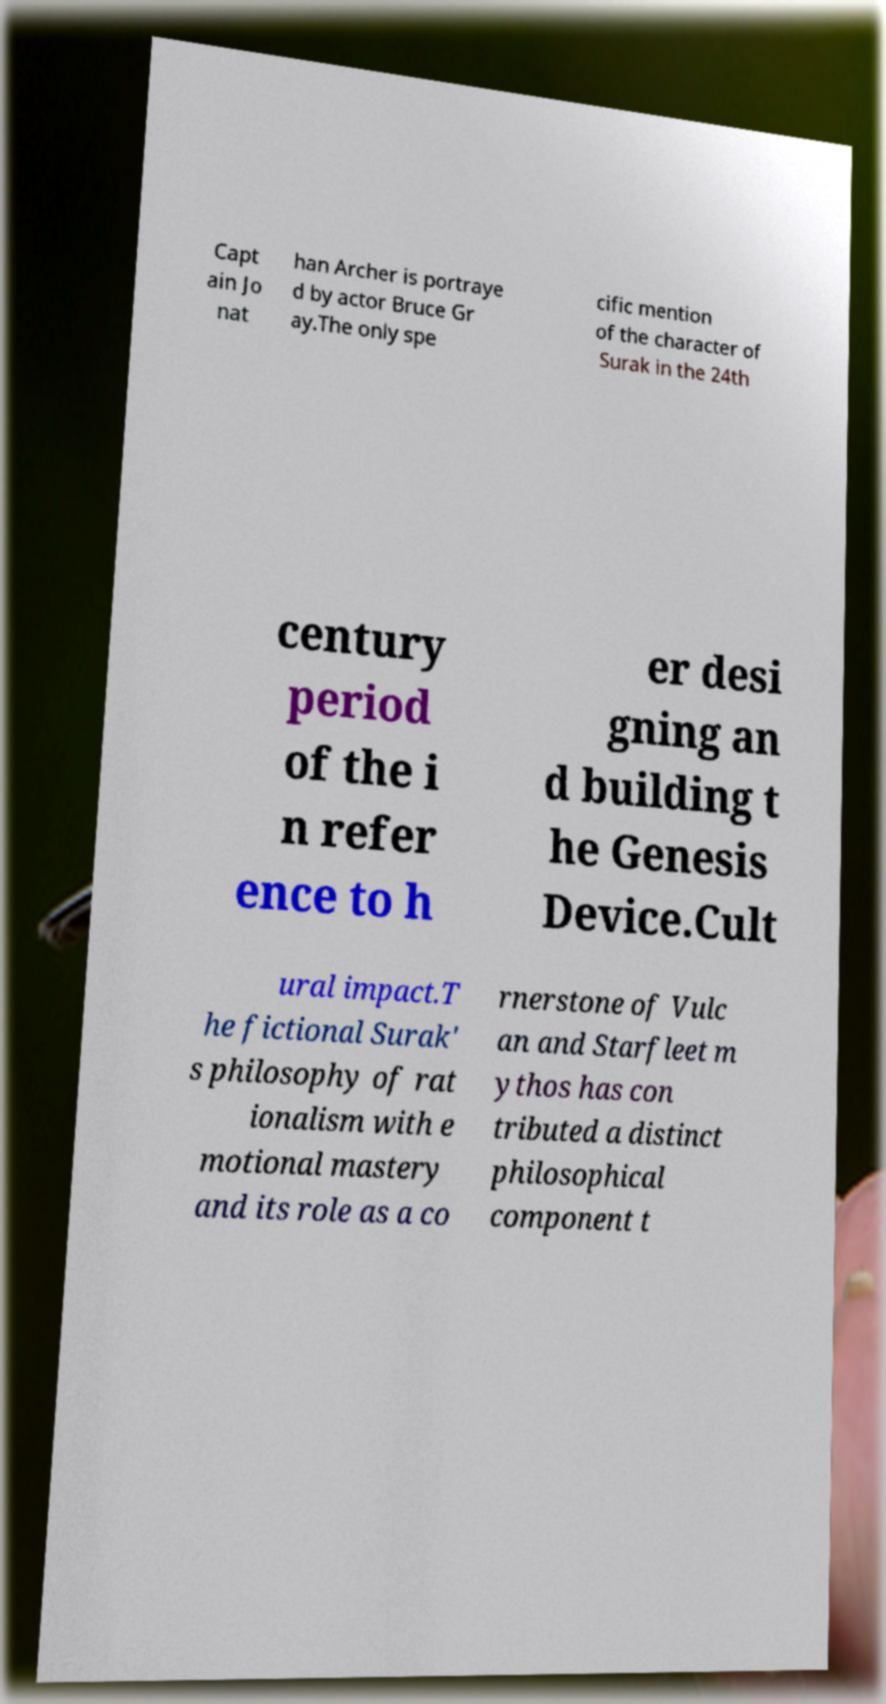Could you assist in decoding the text presented in this image and type it out clearly? Capt ain Jo nat han Archer is portraye d by actor Bruce Gr ay.The only spe cific mention of the character of Surak in the 24th century period of the i n refer ence to h er desi gning an d building t he Genesis Device.Cult ural impact.T he fictional Surak' s philosophy of rat ionalism with e motional mastery and its role as a co rnerstone of Vulc an and Starfleet m ythos has con tributed a distinct philosophical component t 